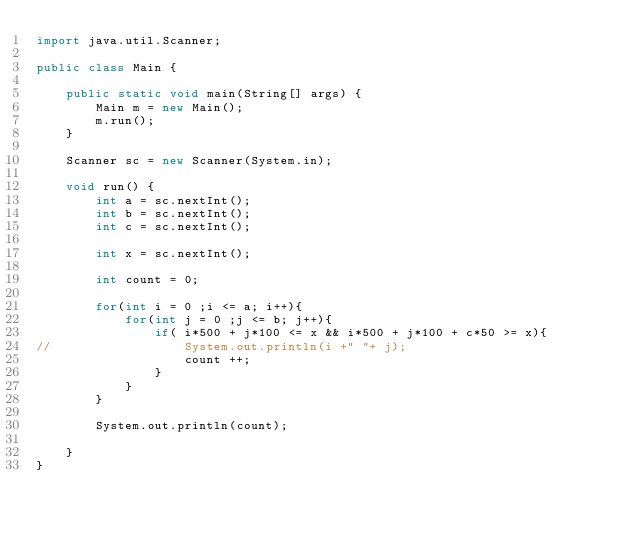Convert code to text. <code><loc_0><loc_0><loc_500><loc_500><_Java_>import java.util.Scanner;

public class Main {

	public static void main(String[] args) {
		Main m = new Main();
		m.run();
	}

	Scanner sc = new Scanner(System.in);

	void run() {
		int a = sc.nextInt();
		int b = sc.nextInt();
		int c = sc.nextInt();
		
		int x = sc.nextInt();
		
		int count = 0;
		
		for(int i = 0 ;i <= a; i++){
			for(int j = 0 ;j <= b; j++){
				if( i*500 + j*100 <= x && i*500 + j*100 + c*50 >= x){
//					System.out.println(i +" "+ j);
					count ++;
				}
			}
		}
		
		System.out.println(count);
		
	}
}
</code> 